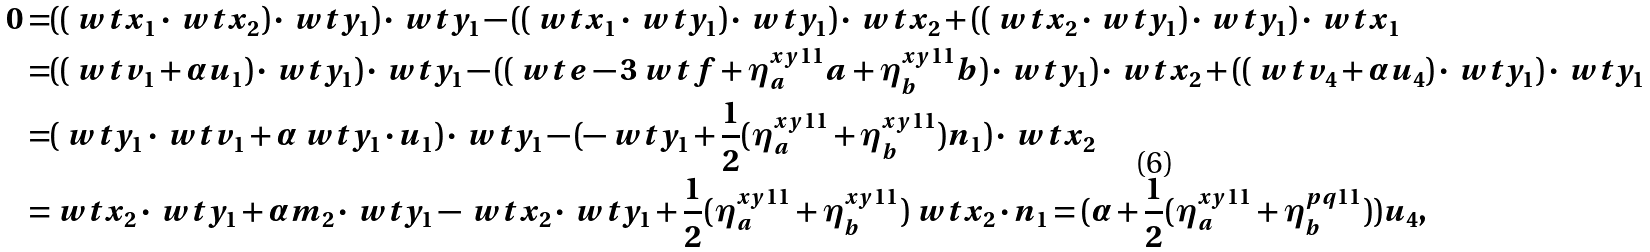<formula> <loc_0><loc_0><loc_500><loc_500>0 = & ( ( \ w t { x } _ { 1 } \cdot \ w t { x } _ { 2 } ) \cdot \ w t { y } _ { 1 } ) \cdot \ w t { y } _ { 1 } - ( ( \ w t { x } _ { 1 } \cdot \ w t { y } _ { 1 } ) \cdot \ w t { y } _ { 1 } ) \cdot \ w t { x } _ { 2 } + ( ( \ w t { x } _ { 2 } \cdot \ w t { y } _ { 1 } ) \cdot \ w t { y } _ { 1 } ) \cdot \ w t { x } _ { 1 } \\ = & ( ( \ w t { v } _ { 1 } + \alpha u _ { 1 } ) \cdot \ w t { y } _ { 1 } ) \cdot \ w t { y } _ { 1 } - ( ( \ w t { e } - 3 \ w t { f } + \eta ^ { x y 1 1 } _ { a } a + \eta ^ { x y 1 1 } _ { b } b ) \cdot \ w t { y } _ { 1 } ) \cdot \ w t { x } _ { 2 } + ( ( \ w t { v } _ { 4 } + \alpha u _ { 4 } ) \cdot \ w t { y } _ { 1 } ) \cdot \ w t { y } _ { 1 } \\ = & ( \ w t { y } _ { 1 } \cdot \ w t { v } _ { 1 } + \alpha \ w t { y } _ { 1 } \cdot u _ { 1 } ) \cdot \ w t { y } _ { 1 } - ( - \ w t { y } _ { 1 } + \frac { 1 } { 2 } ( \eta ^ { x y 1 1 } _ { a } + \eta ^ { x y 1 1 } _ { b } ) n _ { 1 } ) \cdot \ w t { x } _ { 2 } \\ = & \ w t { x } _ { 2 } \cdot \ w t { y } _ { 1 } + \alpha m _ { 2 } \cdot \ w t { y } _ { 1 } - \ w t { x } _ { 2 } \cdot \ w t { y } _ { 1 } + \frac { 1 } { 2 } ( \eta ^ { x y 1 1 } _ { a } + \eta ^ { x y 1 1 } _ { b } ) \ w t { x } _ { 2 } \cdot n _ { 1 } = ( \alpha + \frac { 1 } { 2 } ( \eta ^ { x y 1 1 } _ { a } + \eta ^ { p q 1 1 } _ { b } ) ) u _ { 4 } ,</formula> 